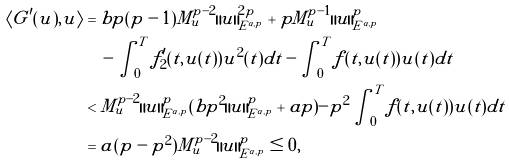Convert formula to latex. <formula><loc_0><loc_0><loc_500><loc_500>\langle G ^ { \prime } ( u ) , u \rangle & = b p ( p - 1 ) M _ { u } ^ { p - 2 } \| u \| _ { E ^ { \alpha , p } } ^ { 2 p } + p M _ { u } ^ { p - 1 } \| u \| _ { E ^ { \alpha , p } } ^ { p } \\ & \quad - \int _ { 0 } ^ { T } f ^ { \prime } _ { 2 } ( t , u ( t ) ) u ^ { 2 } ( t ) d t - \int _ { 0 } ^ { T } f ( t , u ( t ) ) u ( t ) d t \\ & < M _ { u } ^ { p - 2 } \| u \| _ { E ^ { \alpha , p } } ^ { p } ( b p ^ { 2 } \| u \| _ { E ^ { \alpha , p } } ^ { p } + a p ) - p ^ { 2 } \int _ { 0 } ^ { T } f ( t , u ( t ) ) u ( t ) d t \\ & = a ( p - p ^ { 2 } ) M _ { u } ^ { p - 2 } \| u \| _ { E ^ { \alpha , p } } ^ { p } \leq 0 ,</formula> 